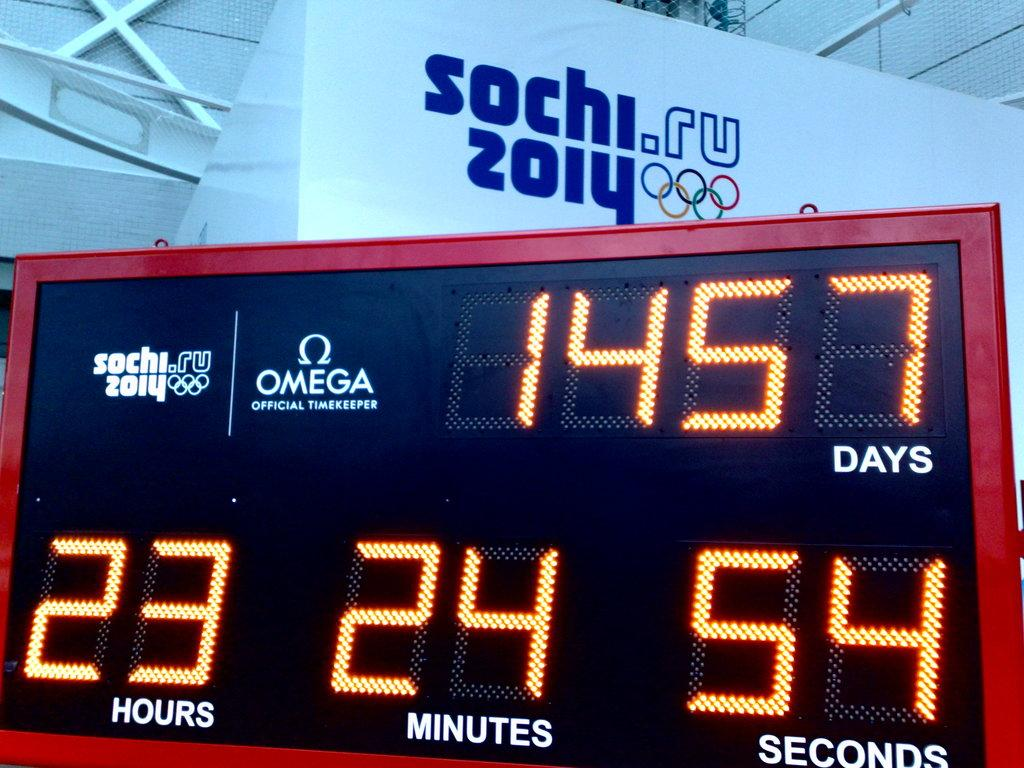<image>
Share a concise interpretation of the image provided. a digital screen with the label 'omega official timekeeper' on it 